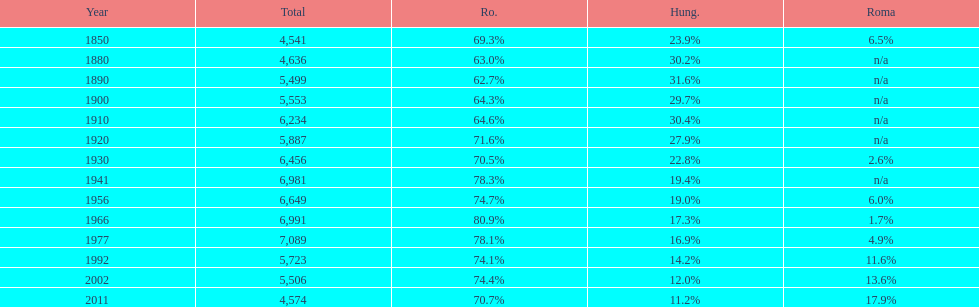What is the number of hungarians in 1850? 23.9%. Give me the full table as a dictionary. {'header': ['Year', 'Total', 'Ro.', 'Hung.', 'Roma'], 'rows': [['1850', '4,541', '69.3%', '23.9%', '6.5%'], ['1880', '4,636', '63.0%', '30.2%', 'n/a'], ['1890', '5,499', '62.7%', '31.6%', 'n/a'], ['1900', '5,553', '64.3%', '29.7%', 'n/a'], ['1910', '6,234', '64.6%', '30.4%', 'n/a'], ['1920', '5,887', '71.6%', '27.9%', 'n/a'], ['1930', '6,456', '70.5%', '22.8%', '2.6%'], ['1941', '6,981', '78.3%', '19.4%', 'n/a'], ['1956', '6,649', '74.7%', '19.0%', '6.0%'], ['1966', '6,991', '80.9%', '17.3%', '1.7%'], ['1977', '7,089', '78.1%', '16.9%', '4.9%'], ['1992', '5,723', '74.1%', '14.2%', '11.6%'], ['2002', '5,506', '74.4%', '12.0%', '13.6%'], ['2011', '4,574', '70.7%', '11.2%', '17.9%']]} 